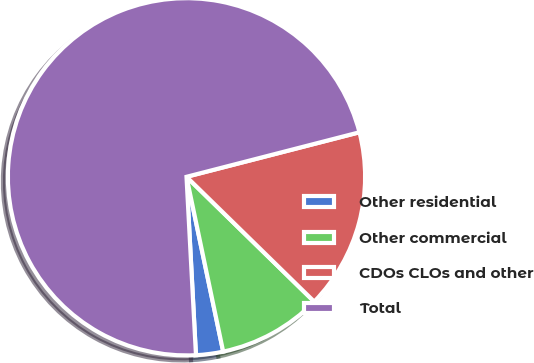Convert chart to OTSL. <chart><loc_0><loc_0><loc_500><loc_500><pie_chart><fcel>Other residential<fcel>Other commercial<fcel>CDOs CLOs and other<fcel>Total<nl><fcel>2.45%<fcel>9.39%<fcel>16.33%<fcel>71.84%<nl></chart> 